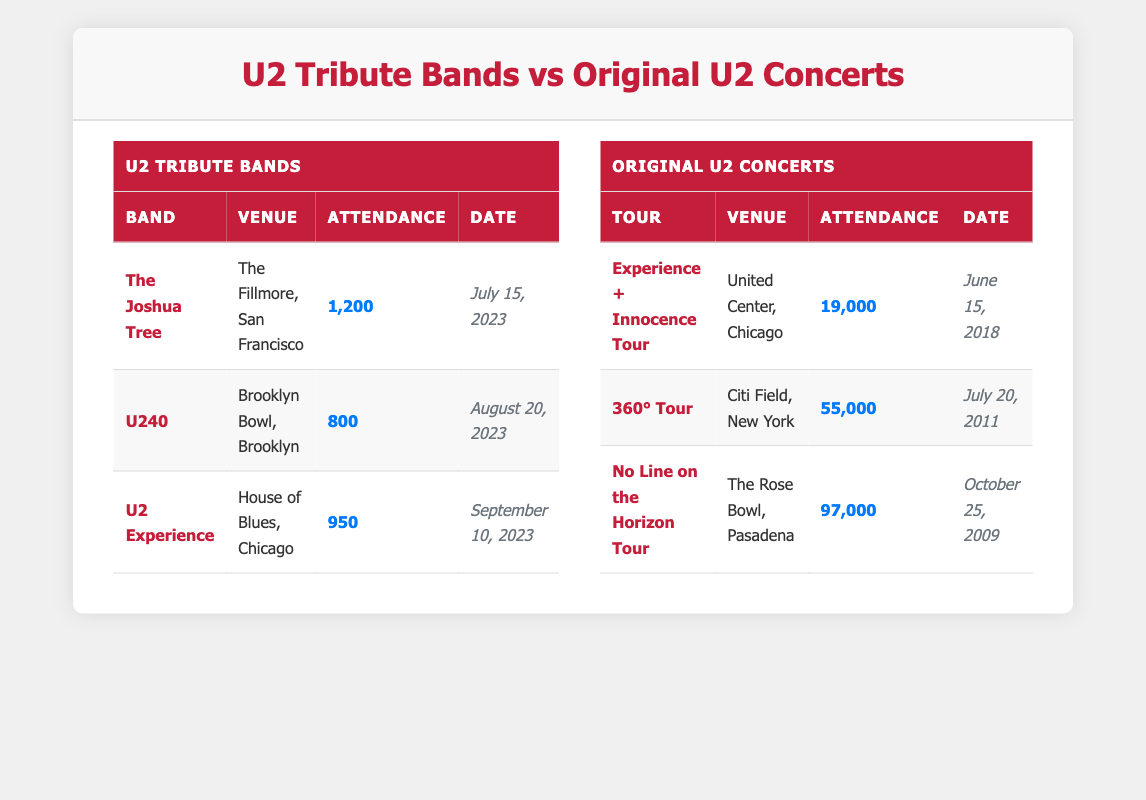What is the highest attendance recorded for a U2 tribute band? The table shows that the highest attendance for a U2 tribute band is 1,200, which corresponds to The Joshua Tree at The Fillmore in San Francisco on July 15, 2023.
Answer: 1,200 How many U2 tribute bands are listed in the table? There are three U2 tribute bands listed in the table: The Joshua Tree, U240, and U2 Experience.
Answer: 3 What is the total attendance for all U2 tribute band shows? To find the total attendance, we add the attendance figures for each band: 1,200 + 800 + 950 = 2,950.
Answer: 2,950 Was the attendance for the original U2 concerts generally higher than that of the U2 tribute bands? Yes, by comparing the maximum attendance for the original U2 concerts (97,000) with the maximum attendance for any U2 tribute band (1,200), it is clear that original U2 concerts had significantly higher attendance.
Answer: Yes What is the average attendance for original U2 concerts? To find the average attendance, we sum the attendance: 19,000 + 55,000 + 97,000 = 171,000, then divide by the number of concerts, which is 3: 171,000 / 3 = 57,000.
Answer: 57,000 Which U2 tribute band had the lowest attendance, and what was the figure? The band with the lowest attendance is U240, with an attendance of 800 at Brooklyn Bowl, Brooklyn on August 20, 2023.
Answer: U240, 800 How many more fans attended the largest original U2 concert compared to the largest U2 tribute band show? The largest original U2 concert had an attendance of 97,000, and the largest tribute band show had 1,200. So, 97,000 - 1,200 = 95,800 more fans.
Answer: 95,800 Which city hosted the most U2 tribute band shows listed in the table? The cities are San Francisco, Brooklyn, and Chicago. Since Chicago hosted one tribute band show and the other two cities hosted one show each, all cities hosted the same amount of U2 tribute band shows: one each.
Answer: All cities hosted one show each 